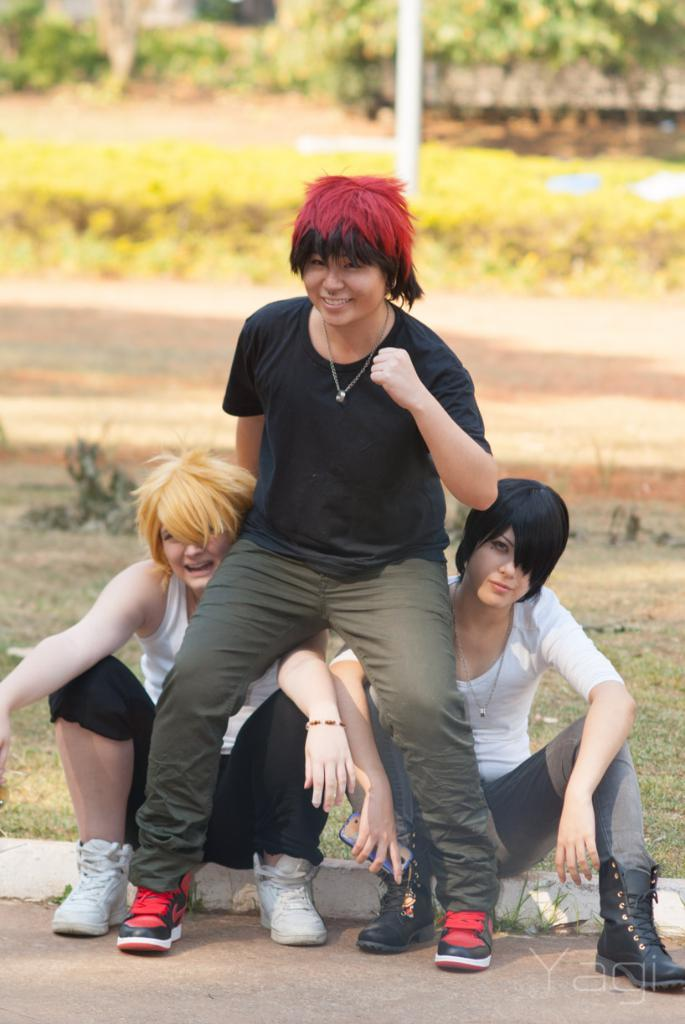How many women are sitting on the ground in the image? There are two women sitting on the ground in the image. What is the position of the third woman in the image? The third woman is sitting on the shoulders of one of the women sitting on the ground. What can be seen in the background of the image? There are plants and trees in the background of the image. What type of game is being played with the glove in the image? There is no glove present in the image, and therefore no game can be observed. 